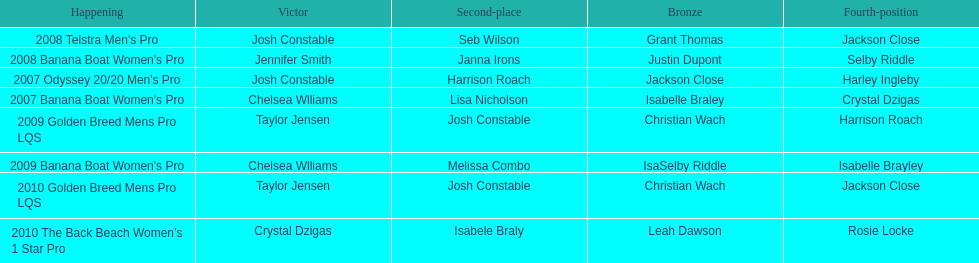In what two races did chelsea williams earn the same rank? 2007 Banana Boat Women's Pro, 2009 Banana Boat Women's Pro. 